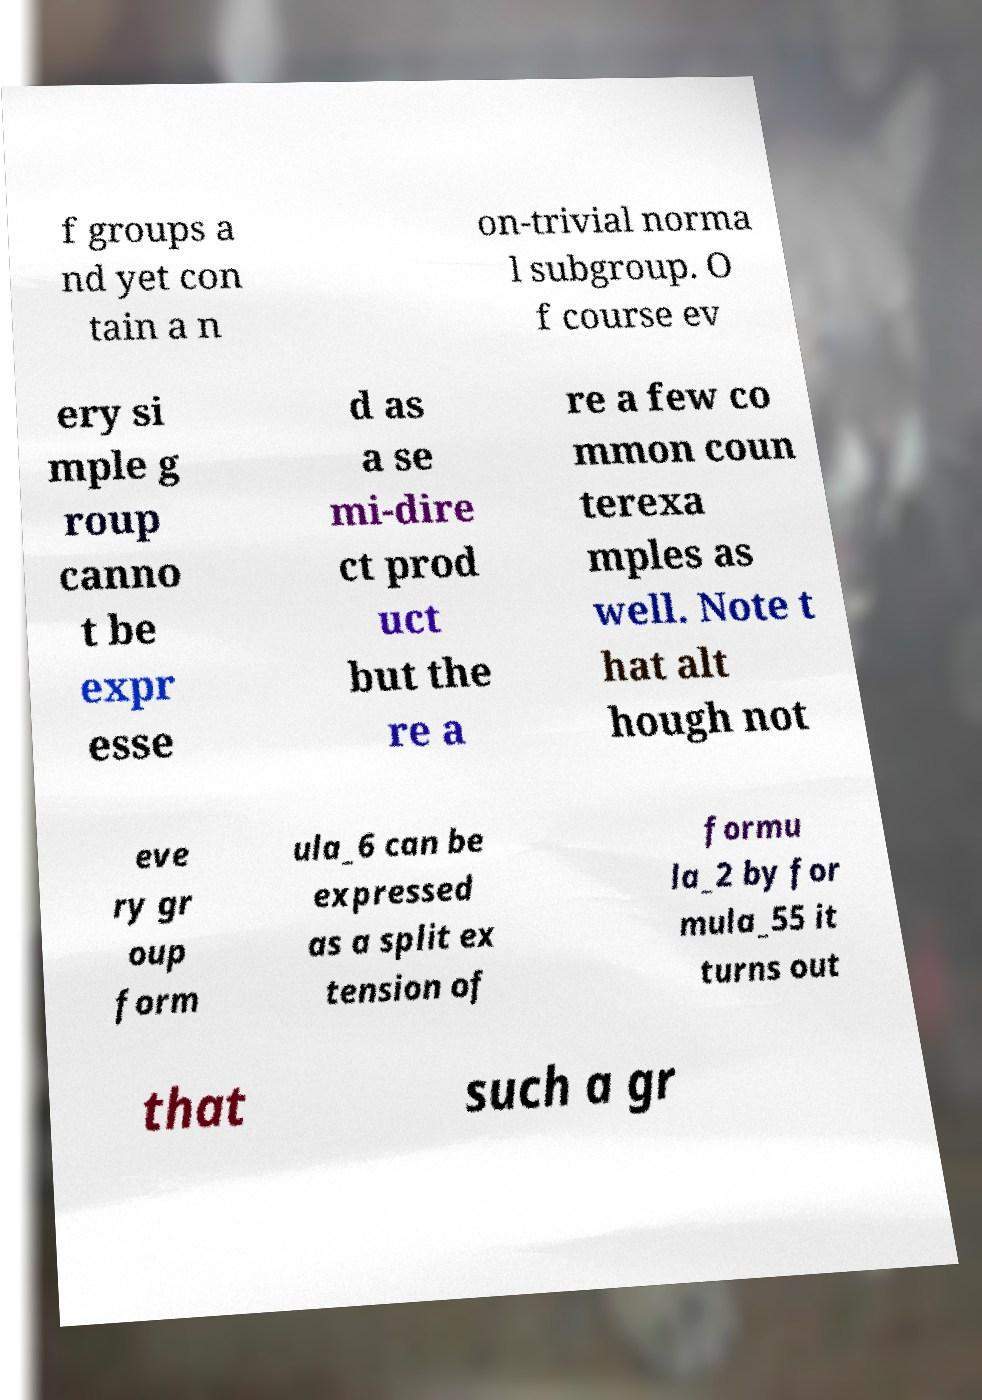Please identify and transcribe the text found in this image. f groups a nd yet con tain a n on-trivial norma l subgroup. O f course ev ery si mple g roup canno t be expr esse d as a se mi-dire ct prod uct but the re a re a few co mmon coun terexa mples as well. Note t hat alt hough not eve ry gr oup form ula_6 can be expressed as a split ex tension of formu la_2 by for mula_55 it turns out that such a gr 